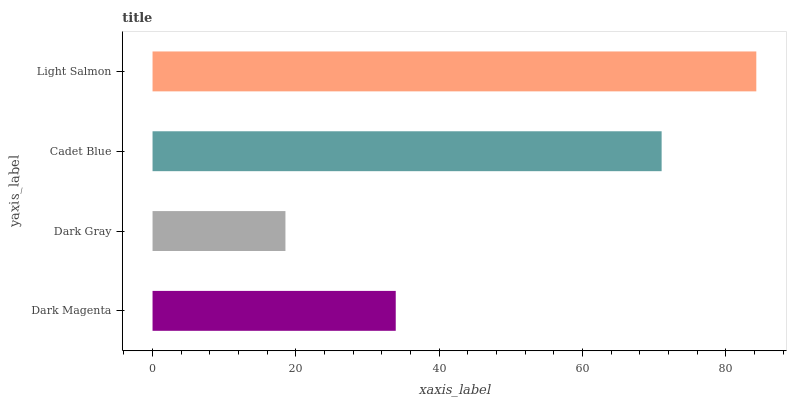Is Dark Gray the minimum?
Answer yes or no. Yes. Is Light Salmon the maximum?
Answer yes or no. Yes. Is Cadet Blue the minimum?
Answer yes or no. No. Is Cadet Blue the maximum?
Answer yes or no. No. Is Cadet Blue greater than Dark Gray?
Answer yes or no. Yes. Is Dark Gray less than Cadet Blue?
Answer yes or no. Yes. Is Dark Gray greater than Cadet Blue?
Answer yes or no. No. Is Cadet Blue less than Dark Gray?
Answer yes or no. No. Is Cadet Blue the high median?
Answer yes or no. Yes. Is Dark Magenta the low median?
Answer yes or no. Yes. Is Light Salmon the high median?
Answer yes or no. No. Is Dark Gray the low median?
Answer yes or no. No. 